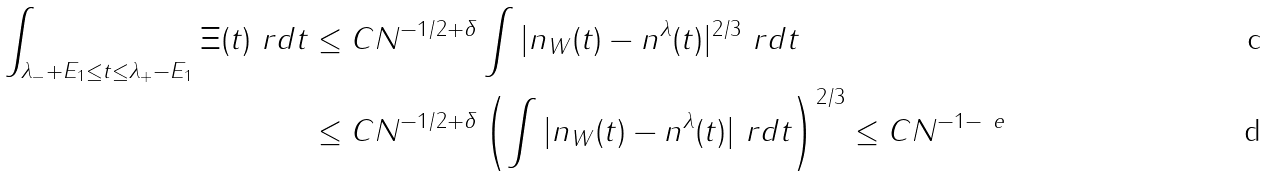Convert formula to latex. <formula><loc_0><loc_0><loc_500><loc_500>\int _ { \lambda _ { - } + E _ { 1 } \leq t \leq \lambda _ { + } - E _ { 1 } } \Xi ( t ) \ r d t & \leq C N ^ { - 1 / 2 + \delta } \int | n _ { W } ( t ) - n ^ { \lambda } ( t ) | ^ { 2 / 3 } \ r d t \\ & \leq C N ^ { - 1 / 2 + \delta } \left ( \int | n _ { W } ( t ) - n ^ { \lambda } ( t ) | \ r d t \right ) ^ { 2 / 3 } \leq C N ^ { - 1 - \ e }</formula> 